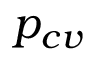Convert formula to latex. <formula><loc_0><loc_0><loc_500><loc_500>p _ { c v }</formula> 